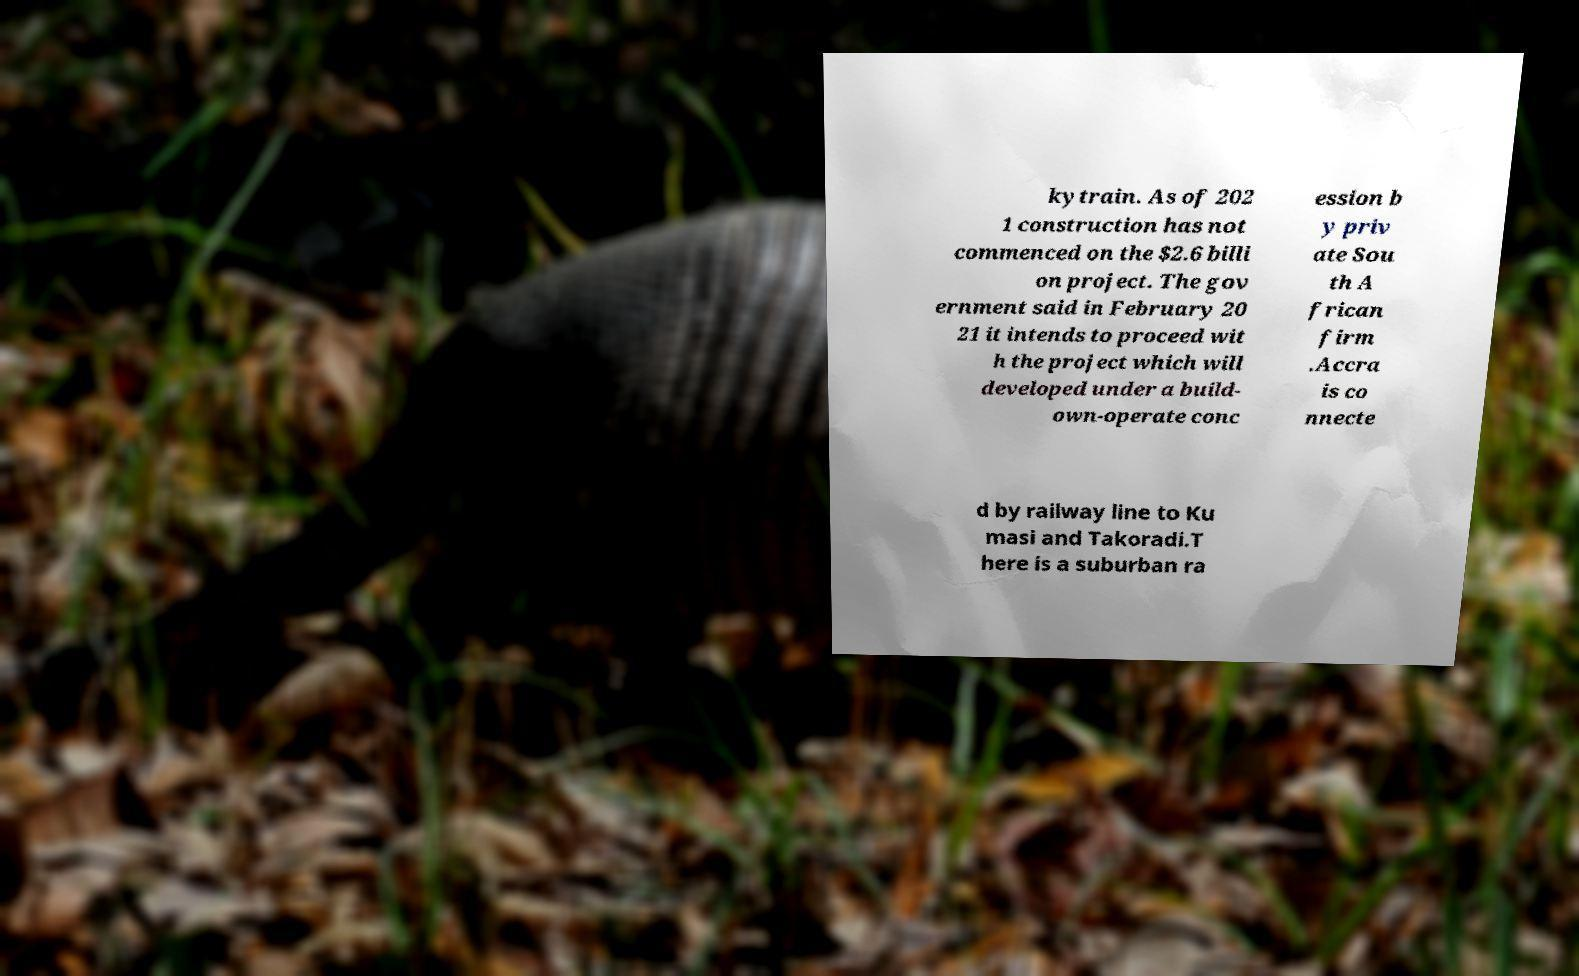I need the written content from this picture converted into text. Can you do that? kytrain. As of 202 1 construction has not commenced on the $2.6 billi on project. The gov ernment said in February 20 21 it intends to proceed wit h the project which will developed under a build- own-operate conc ession b y priv ate Sou th A frican firm .Accra is co nnecte d by railway line to Ku masi and Takoradi.T here is a suburban ra 